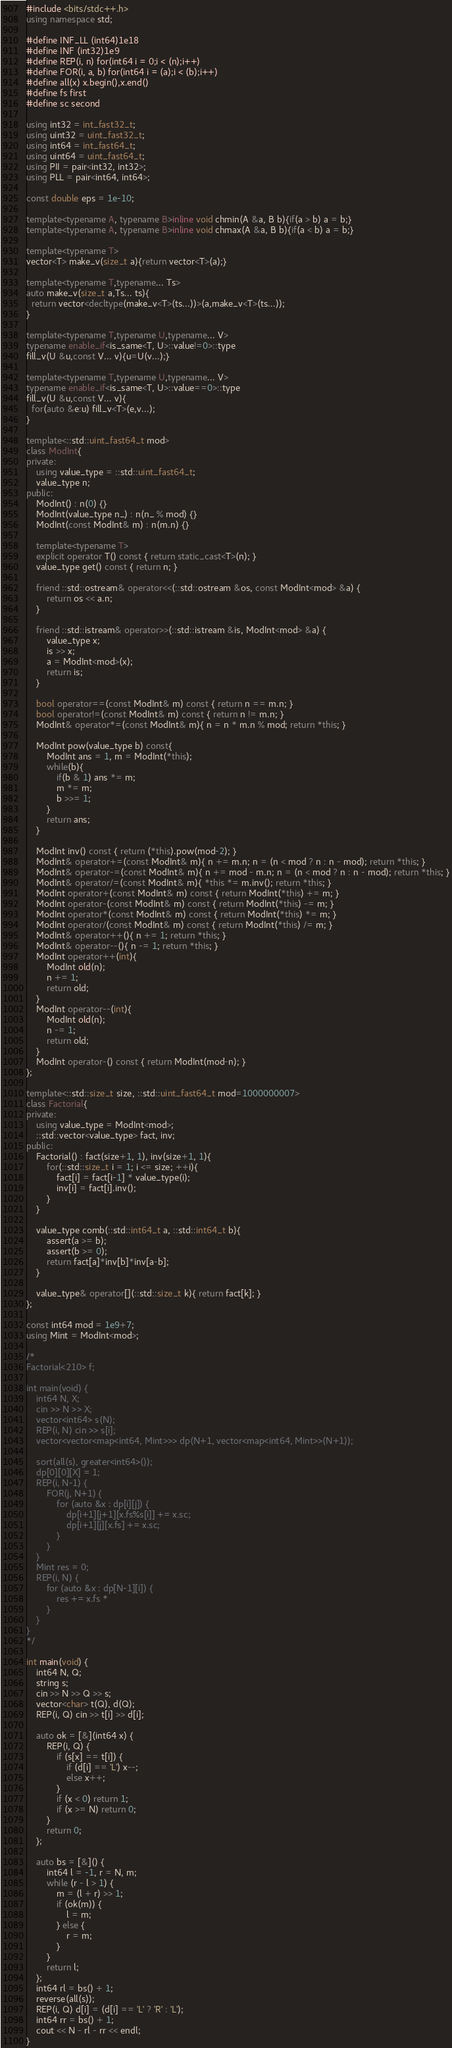Convert code to text. <code><loc_0><loc_0><loc_500><loc_500><_C++_>#include <bits/stdc++.h>
using namespace std;

#define INF_LL (int64)1e18
#define INF (int32)1e9
#define REP(i, n) for(int64 i = 0;i < (n);i++)
#define FOR(i, a, b) for(int64 i = (a);i < (b);i++)
#define all(x) x.begin(),x.end()
#define fs first
#define sc second

using int32 = int_fast32_t;
using uint32 = uint_fast32_t;
using int64 = int_fast64_t;
using uint64 = uint_fast64_t;
using PII = pair<int32, int32>;
using PLL = pair<int64, int64>;

const double eps = 1e-10;

template<typename A, typename B>inline void chmin(A &a, B b){if(a > b) a = b;}
template<typename A, typename B>inline void chmax(A &a, B b){if(a < b) a = b;}

template<typename T>
vector<T> make_v(size_t a){return vector<T>(a);}

template<typename T,typename... Ts>
auto make_v(size_t a,Ts... ts){
  return vector<decltype(make_v<T>(ts...))>(a,make_v<T>(ts...));
}

template<typename T,typename U,typename... V>
typename enable_if<is_same<T, U>::value!=0>::type
fill_v(U &u,const V... v){u=U(v...);}

template<typename T,typename U,typename... V>
typename enable_if<is_same<T, U>::value==0>::type
fill_v(U &u,const V... v){
  for(auto &e:u) fill_v<T>(e,v...);
}

template<::std::uint_fast64_t mod>
class ModInt{
private:
	using value_type = ::std::uint_fast64_t;
	value_type n;
public:
	ModInt() : n(0) {}
	ModInt(value_type n_) : n(n_ % mod) {}
	ModInt(const ModInt& m) : n(m.n) {}

	template<typename T>
	explicit operator T() const { return static_cast<T>(n); }
	value_type get() const { return n; }

	friend ::std::ostream& operator<<(::std::ostream &os, const ModInt<mod> &a) {
		return os << a.n;
	}

	friend ::std::istream& operator>>(::std::istream &is, ModInt<mod> &a) {
		value_type x;
		is >> x;
		a = ModInt<mod>(x);
		return is;
	}

	bool operator==(const ModInt& m) const { return n == m.n; }
	bool operator!=(const ModInt& m) const { return n != m.n; }
	ModInt& operator*=(const ModInt& m){ n = n * m.n % mod; return *this; }

	ModInt pow(value_type b) const{
		ModInt ans = 1, m = ModInt(*this);
		while(b){
			if(b & 1) ans *= m;
			m *= m;
			b >>= 1;
		}
		return ans;
	}

	ModInt inv() const { return (*this).pow(mod-2); }
	ModInt& operator+=(const ModInt& m){ n += m.n; n = (n < mod ? n : n - mod); return *this; }
	ModInt& operator-=(const ModInt& m){ n += mod - m.n; n = (n < mod ? n : n - mod); return *this; }
	ModInt& operator/=(const ModInt& m){ *this *= m.inv(); return *this; }
	ModInt operator+(const ModInt& m) const { return ModInt(*this) += m; }
	ModInt operator-(const ModInt& m) const { return ModInt(*this) -= m; }
	ModInt operator*(const ModInt& m) const { return ModInt(*this) *= m; }
	ModInt operator/(const ModInt& m) const { return ModInt(*this) /= m; }
	ModInt& operator++(){ n += 1; return *this; }
	ModInt& operator--(){ n -= 1; return *this; }
	ModInt operator++(int){
		ModInt old(n);
		n += 1;
		return old;
	}
	ModInt operator--(int){
		ModInt old(n);
		n -= 1;
		return old;
	}
	ModInt operator-() const { return ModInt(mod-n); }
};

template<::std::size_t size, ::std::uint_fast64_t mod=1000000007>
class Factorial{
private:
	using value_type = ModInt<mod>;
	::std::vector<value_type> fact, inv;
public:
	Factorial() : fact(size+1, 1), inv(size+1, 1){
		for(::std::size_t i = 1; i <= size; ++i){
			fact[i] = fact[i-1] * value_type(i);
			inv[i] = fact[i].inv();
		}
	}

	value_type comb(::std::int64_t a, ::std::int64_t b){
		assert(a >= b);
		assert(b >= 0);
		return fact[a]*inv[b]*inv[a-b];
	}

	value_type& operator[](::std::size_t k){ return fact[k]; }
};

const int64 mod = 1e9+7;
using Mint = ModInt<mod>;

/*
Factorial<210> f;

int main(void) {
	int64 N, X;
	cin >> N >> X;
	vector<int64> s(N);
	REP(i, N) cin >> s[i];
	vector<vector<map<int64, Mint>>> dp(N+1, vector<map<int64, Mint>>(N+1));

	sort(all(s), greater<int64>());
	dp[0][0][X] = 1;
	REP(i, N-1) {
		FOR(j, N+1) {
			for (auto &x : dp[i][j]) {
				dp[i+1][j+1][x.fs%s[i]] += x.sc;
				dp[i+1][j][x.fs] += x.sc;
			}
		}
	}
	Mint res = 0;
	REP(i, N) {
		for (auto &x : dp[N-1][i]) {
			res += x.fs * 
		}
	}
}
*/

int main(void) {
	int64 N, Q;
	string s;
	cin >> N >> Q >> s;
	vector<char> t(Q), d(Q);
	REP(i, Q) cin >> t[i] >> d[i];

	auto ok = [&](int64 x) {
		REP(i, Q) {
			if (s[x] == t[i]) {
				if (d[i] == 'L') x--;
				else x++;
			}
			if (x < 0) return 1;
			if (x >= N) return 0;
		}
		return 0;
	};

	auto bs = [&]() {
		int64 l = -1, r = N, m;
		while (r - l > 1) {
			m = (l + r) >> 1;
			if (ok(m)) {
				l = m;
			} else {
				r = m;
			}
		}
		return l;
	};
	int64 rl = bs() + 1;
	reverse(all(s));
	REP(i, Q) d[i] = (d[i] == 'L' ? 'R' : 'L');
	int64 rr = bs() + 1;
	cout << N - rl - rr << endl;
}
</code> 